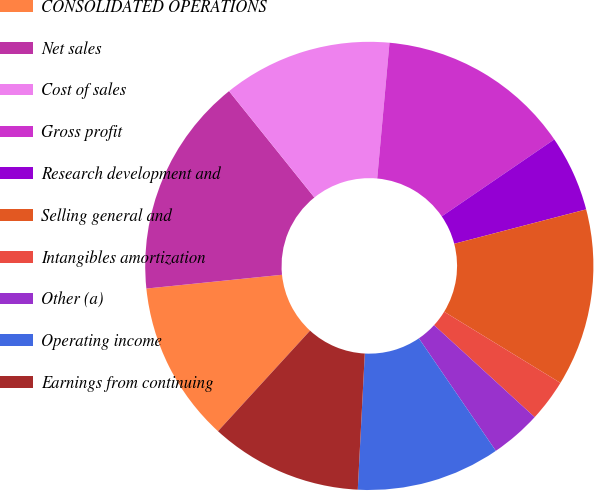Convert chart. <chart><loc_0><loc_0><loc_500><loc_500><pie_chart><fcel>CONSOLIDATED OPERATIONS<fcel>Net sales<fcel>Cost of sales<fcel>Gross profit<fcel>Research development and<fcel>Selling general and<fcel>Intangibles amortization<fcel>Other (a)<fcel>Operating income<fcel>Earnings from continuing<nl><fcel>11.59%<fcel>15.85%<fcel>12.2%<fcel>14.02%<fcel>5.49%<fcel>12.8%<fcel>3.05%<fcel>3.66%<fcel>10.37%<fcel>10.98%<nl></chart> 